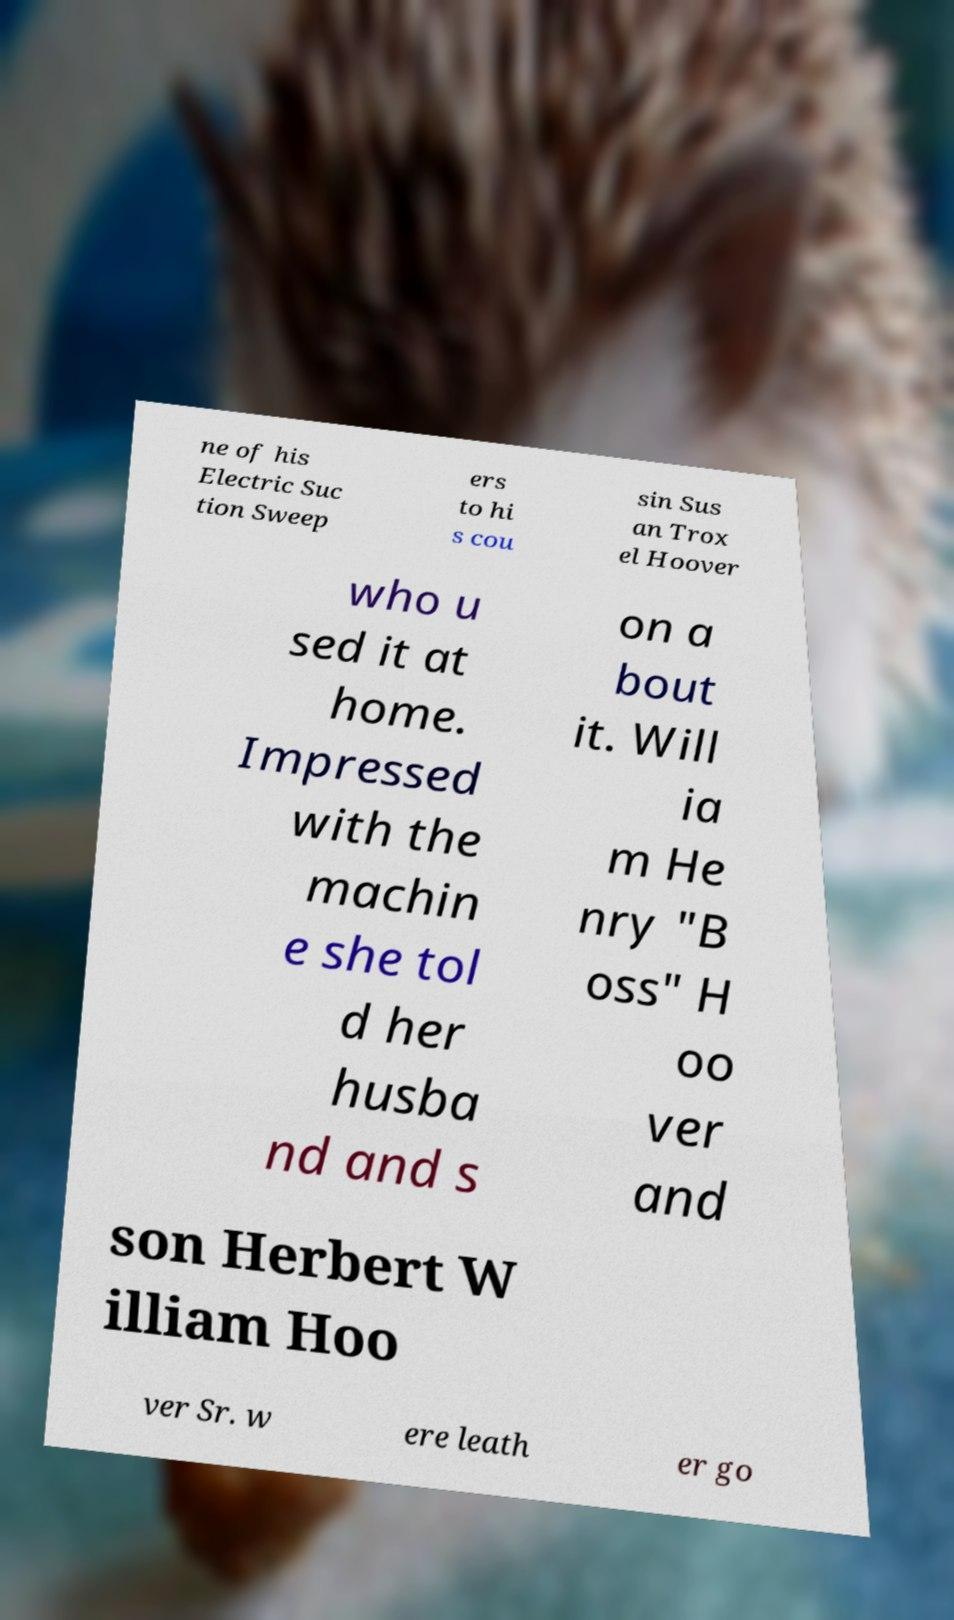Please identify and transcribe the text found in this image. ne of his Electric Suc tion Sweep ers to hi s cou sin Sus an Trox el Hoover who u sed it at home. Impressed with the machin e she tol d her husba nd and s on a bout it. Will ia m He nry "B oss" H oo ver and son Herbert W illiam Hoo ver Sr. w ere leath er go 